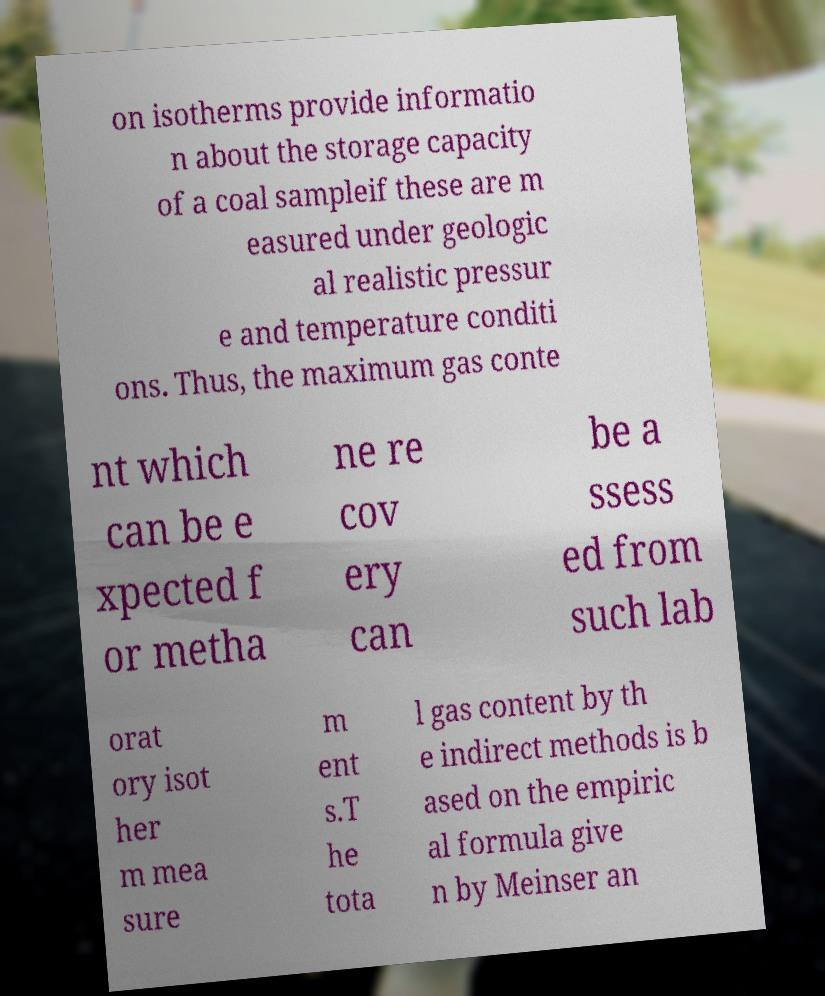There's text embedded in this image that I need extracted. Can you transcribe it verbatim? on isotherms provide informatio n about the storage capacity of a coal sampleif these are m easured under geologic al realistic pressur e and temperature conditi ons. Thus, the maximum gas conte nt which can be e xpected f or metha ne re cov ery can be a ssess ed from such lab orat ory isot her m mea sure m ent s.T he tota l gas content by th e indirect methods is b ased on the empiric al formula give n by Meinser an 